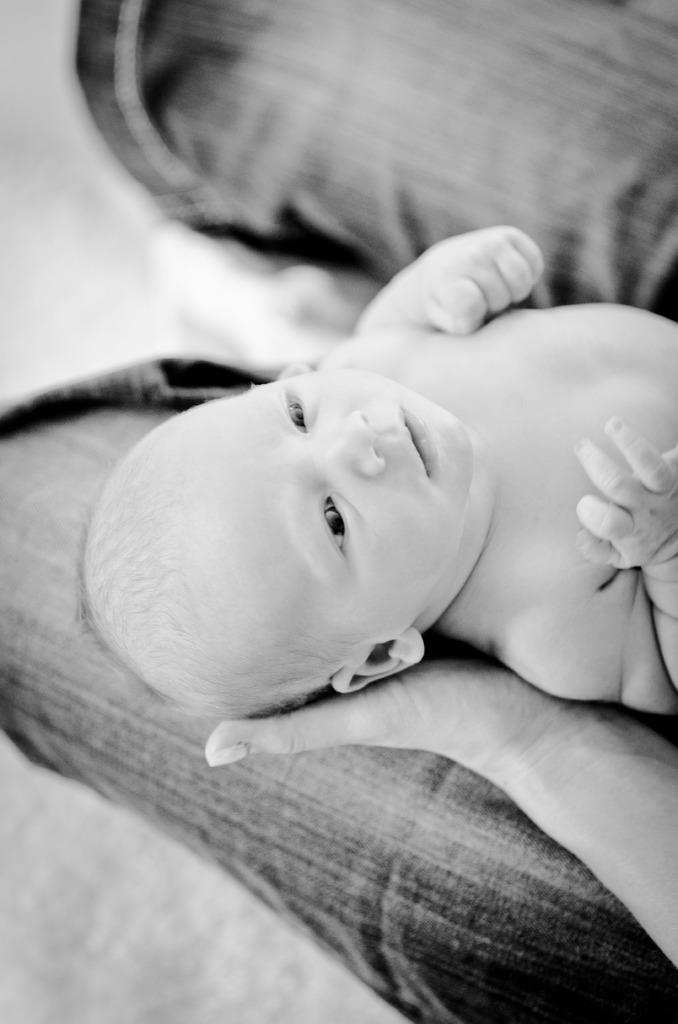What is the main subject of the picture? The main subject of the picture is a baby. What is the baby's position in the image? The baby is being held by a person. Can you describe the background of the image? The background of the image is blurry. What type of insurance is being discussed in the image? There is no discussion of insurance in the image. 